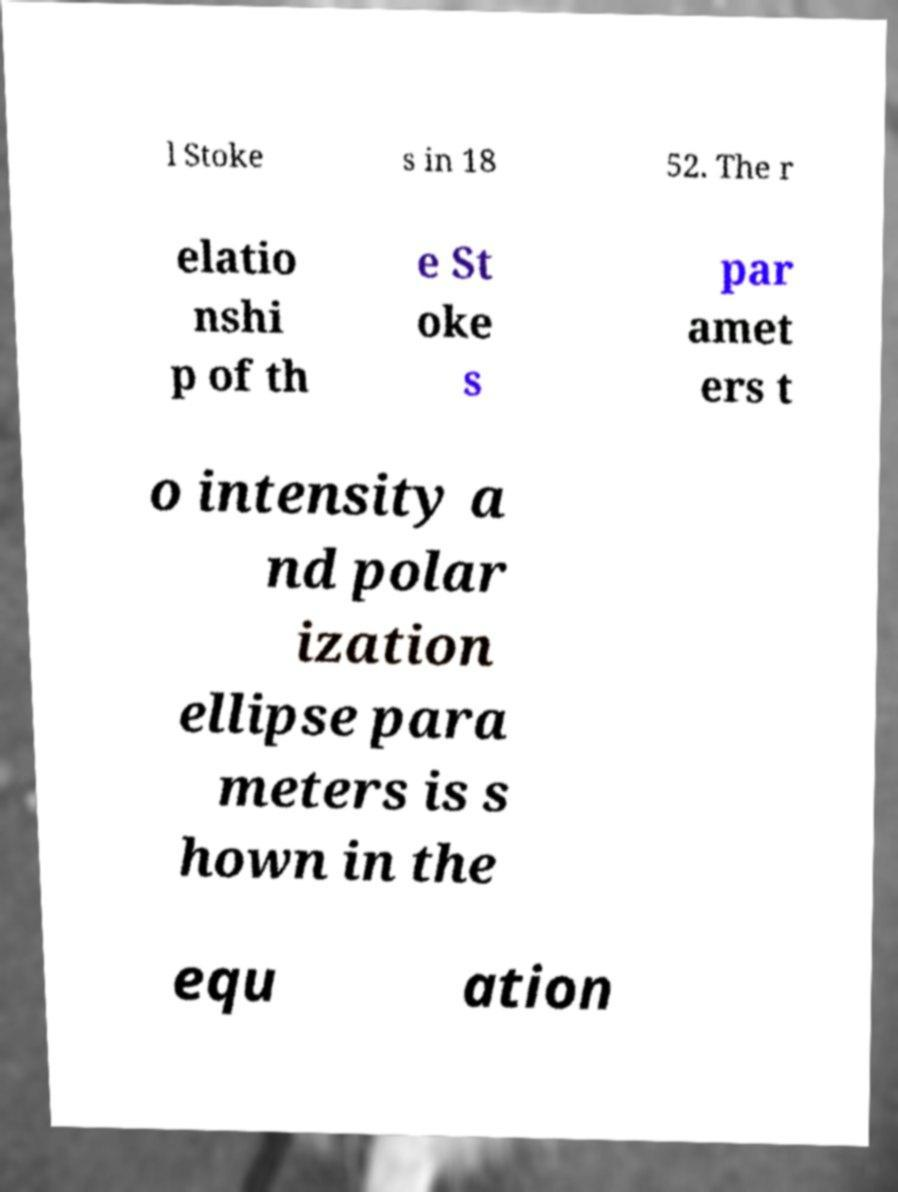Can you accurately transcribe the text from the provided image for me? l Stoke s in 18 52. The r elatio nshi p of th e St oke s par amet ers t o intensity a nd polar ization ellipse para meters is s hown in the equ ation 